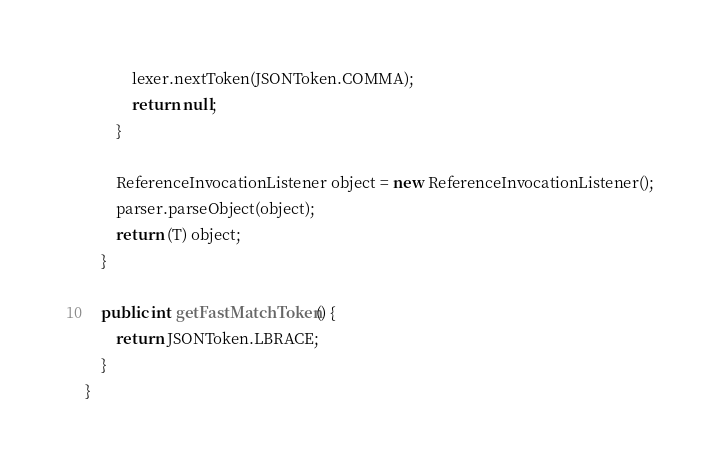<code> <loc_0><loc_0><loc_500><loc_500><_Java_>            lexer.nextToken(JSONToken.COMMA);
            return null;
        }

        ReferenceInvocationListener object = new ReferenceInvocationListener();
        parser.parseObject(object);
        return (T) object;
    }

    public int getFastMatchToken() {
        return JSONToken.LBRACE;
    }
}
</code> 